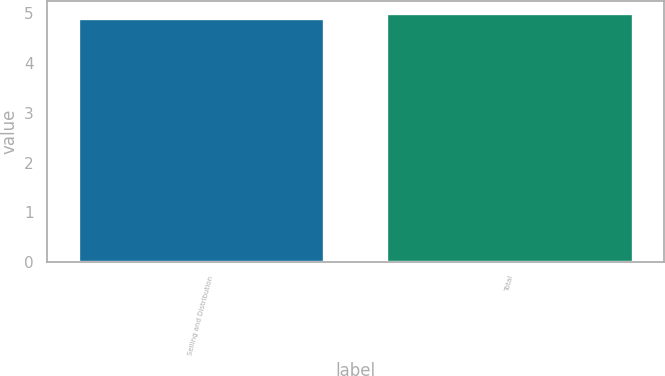Convert chart. <chart><loc_0><loc_0><loc_500><loc_500><bar_chart><fcel>Selling and Distribution<fcel>Total<nl><fcel>4.9<fcel>5<nl></chart> 